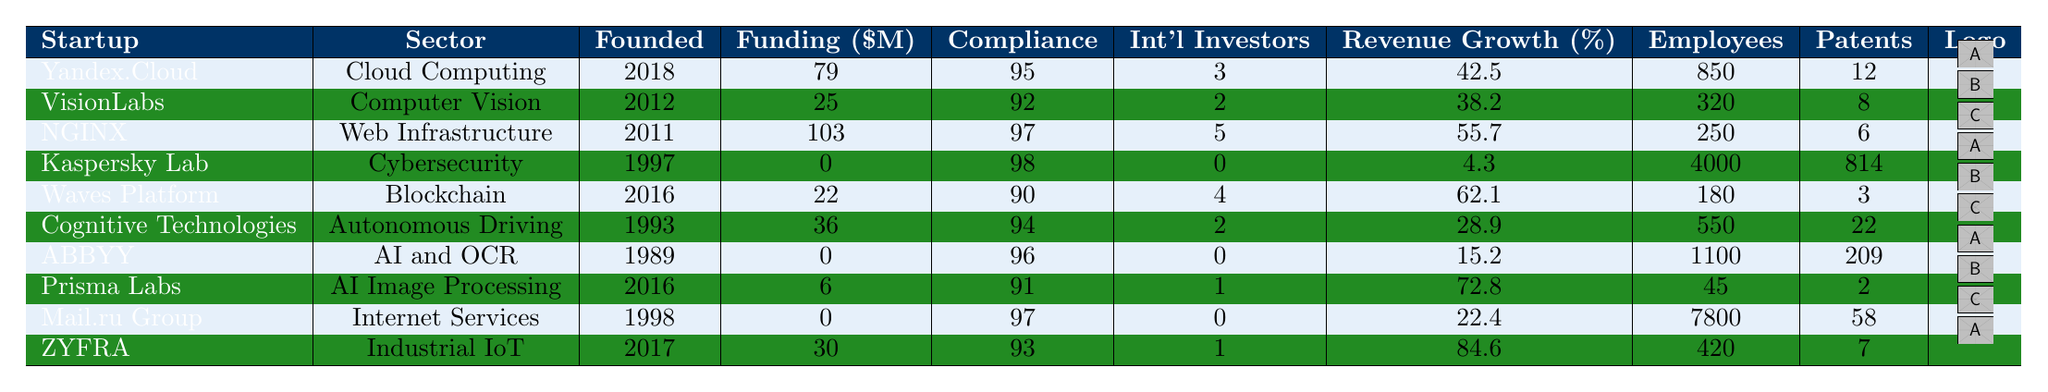What is the total funding for NGINX? The table lists NGINX's total funding amount in the corresponding column, which is $103 million.
Answer: 103 million Which startup has the highest compliance score? By reviewing the compliance score column, Kaspersky Lab has the highest score at 98.
Answer: Kaspersky Lab What is the revenue growth percentage of Waves Platform? The revenue growth percentage is indicated in the table under the revenue growth column for Waves Platform, which is 62.1%.
Answer: 62.1% How many patents have been filed by ABBYY? The table shows that ABBYY has filed 209 patents as stated in the corresponding patents column.
Answer: 209 Which startup has the smallest employee count? Looking at the employee count column, Prisma Labs has the smallest count at 45 employees.
Answer: 45 What is the difference in revenue growth between Yandex.Cloud and VisionLabs? Yandex.Cloud has a revenue growth of 42.5% and VisionLabs has 38.2%. The difference is calculated as 42.5 - 38.2 = 4.3%.
Answer: 4.3% What is the average total funding of all the startups listed in the table? Adding the total funding amounts (79 + 25 + 103 + 0 + 22 + 36 + 0 + 6 + 0 + 30) gives 301 million. There are 10 startups, so the average is 301/10 = 30.1 million.
Answer: 30.1 million Is it true that all startups have received international funding? The table indicates that Kaspersky Lab, ABBYY, and Mail.ru Group have zero international investors, which makes the statement false.
Answer: No Which sector does ZYFRA operate in, and what is its revenue growth percentage? The sector for ZYFRA is Industrial IoT, and its revenue growth percentage is 84.6%, both of which can be found in the corresponding columns.
Answer: Industrial IoT, 84.6% What is the total number of patents filed among the top three startups with the highest number of patents? The top three in terms of patents filed are Kaspersky Lab (814), ABBYY (209), and Cognitive Technologies (22). Adding those gives 814 + 209 + 22 = 1045 patents.
Answer: 1045 